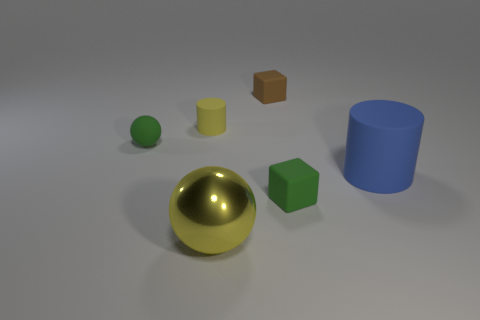Is there any other thing that has the same material as the large yellow thing?
Provide a short and direct response. No. What is the color of the big shiny ball?
Provide a succinct answer. Yellow. There is a metal ball; is its color the same as the rubber cylinder that is behind the large matte object?
Your answer should be very brief. Yes. What size is the blue cylinder that is the same material as the tiny brown thing?
Provide a short and direct response. Large. Is there a small rubber cylinder of the same color as the metallic object?
Offer a very short reply. Yes. How many things are either matte cylinders left of the big matte cylinder or tiny matte cylinders?
Provide a short and direct response. 1. Does the big yellow thing have the same material as the small green thing on the right side of the yellow sphere?
Provide a succinct answer. No. What is the size of the thing that is the same color as the small ball?
Your response must be concise. Small. Are there any cylinders made of the same material as the green sphere?
Your answer should be compact. Yes. What number of things are either green things that are right of the small yellow matte thing or small green objects that are in front of the big blue cylinder?
Ensure brevity in your answer.  1. 